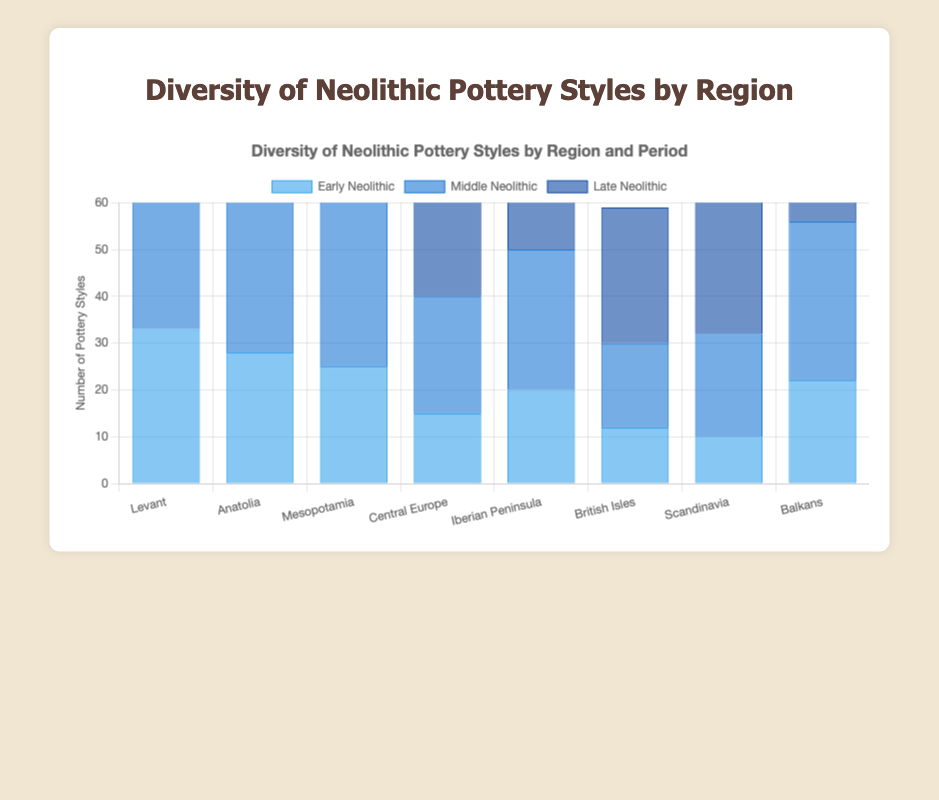Which region has the highest diversity of pottery styles in the Late Neolithic period? Look at the Late Neolithic bars for all regions. The highest bar represents the region with the most styles, which is the Levant with 54 styles.
Answer: Levant Which region shows the largest increase in pottery styles from the Early Neolithic to the Late Neolithic period? Calculate the difference between the Late Neolithic and Early Neolithic periods for each region: Levant (54-33=21), Anatolia (47-28=19), Mesopotamia (52-25=27), Central Europe (38-15=23), Iberian Peninsula (44-20=24), British Isles (29-12=17), Scandinavia (35-10=25), Balkans (46-22=24). Mesopotamia has the largest increase with 27.
Answer: Mesopotamia What is the total number of pottery styles in Central Europe across all three Neolithic periods? Sum the values for Central Europe: Early Neolithic (15) + Middle Neolithic (25) + Late Neolithic (38) = 78.
Answer: 78 How does the diversity of pottery styles in the Iberian Peninsula in the Middle Neolithic compare to that in the British Isles in the same period? Compare the Middle Neolithic bars for both regions. The Iberian Peninsula has 30 while the British Isles has 18, so the Iberian Peninsula has more.
Answer: Iberian Peninsula Which period shows the highest average diversity of pottery styles across all regions? Calculate the average for each period: Early Neolithic (33+28+25+15+20+12+10+22)/8 = 20.625, Middle Neolithic (48+35+40+25+30+18+22+34)/8 = 31.5, Late Neolithic (54+47+52+38+44+29+35+46)/8 = 43.125. The Late Neolithic period has the highest average of 43.125.
Answer: Late Neolithic Which region shows the smallest relative increase in pottery styles from the Early to the Late Neolithic? Calculate the relative increase as a ratio for each region: Levant (54-33)/33 = 0.636, Anatolia (47-28)/28 = 0.679, Mesopotamia (52-25)/25 = 1.08, Central Europe (38-15)/15 = 1.533, Iberian Peninsula (44-20)/20 = 1.2, British Isles (29-12)/12 = 1.417, Scandinavia (35-10)/10 = 2.5, Balkans (46-22)/22 = 1.091. Levant has the smallest relative increase of 0.636.
Answer: Levant What is the median number of pottery styles in the Early Neolithic period across all regions? List the Early Neolithic values in ascending order: 10, 12, 15, 20, 22, 25, 28, 33. The median, or middle number, for this even-numbered dataset is the average of the 4th and 5th values (20+22)/2 = 21.
Answer: 21 Which region shows the greatest consistency in the number of pottery styles across all three Neolithic periods? Calculate the standard deviation for each region's three periods and compare them. Lower standard deviation indicates more consistency. Levant (std=10.89), Anatolia (std=9.85), Mesopotamia (std=11.14), Central Europe (std=11.93), Iberian Peninsula (std=12.49), British Isles (std=8.63), Scandinavia (std=12.91), Balkans (std=10.04). The British Isles has the lowest standard deviation of 8.63.
Answer: British Isles 